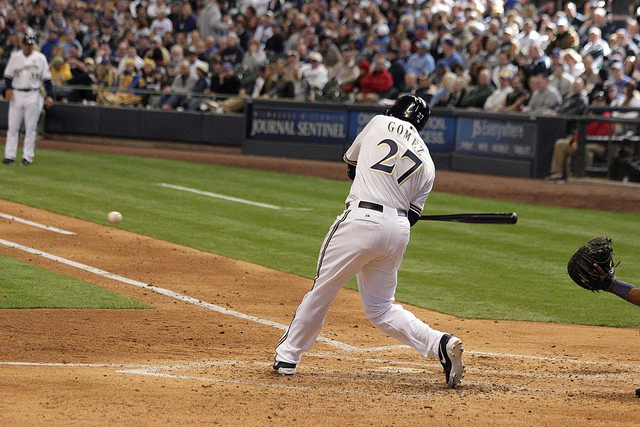Please identify all text content in this image. 27 GOM MEZ Sentinel GO 